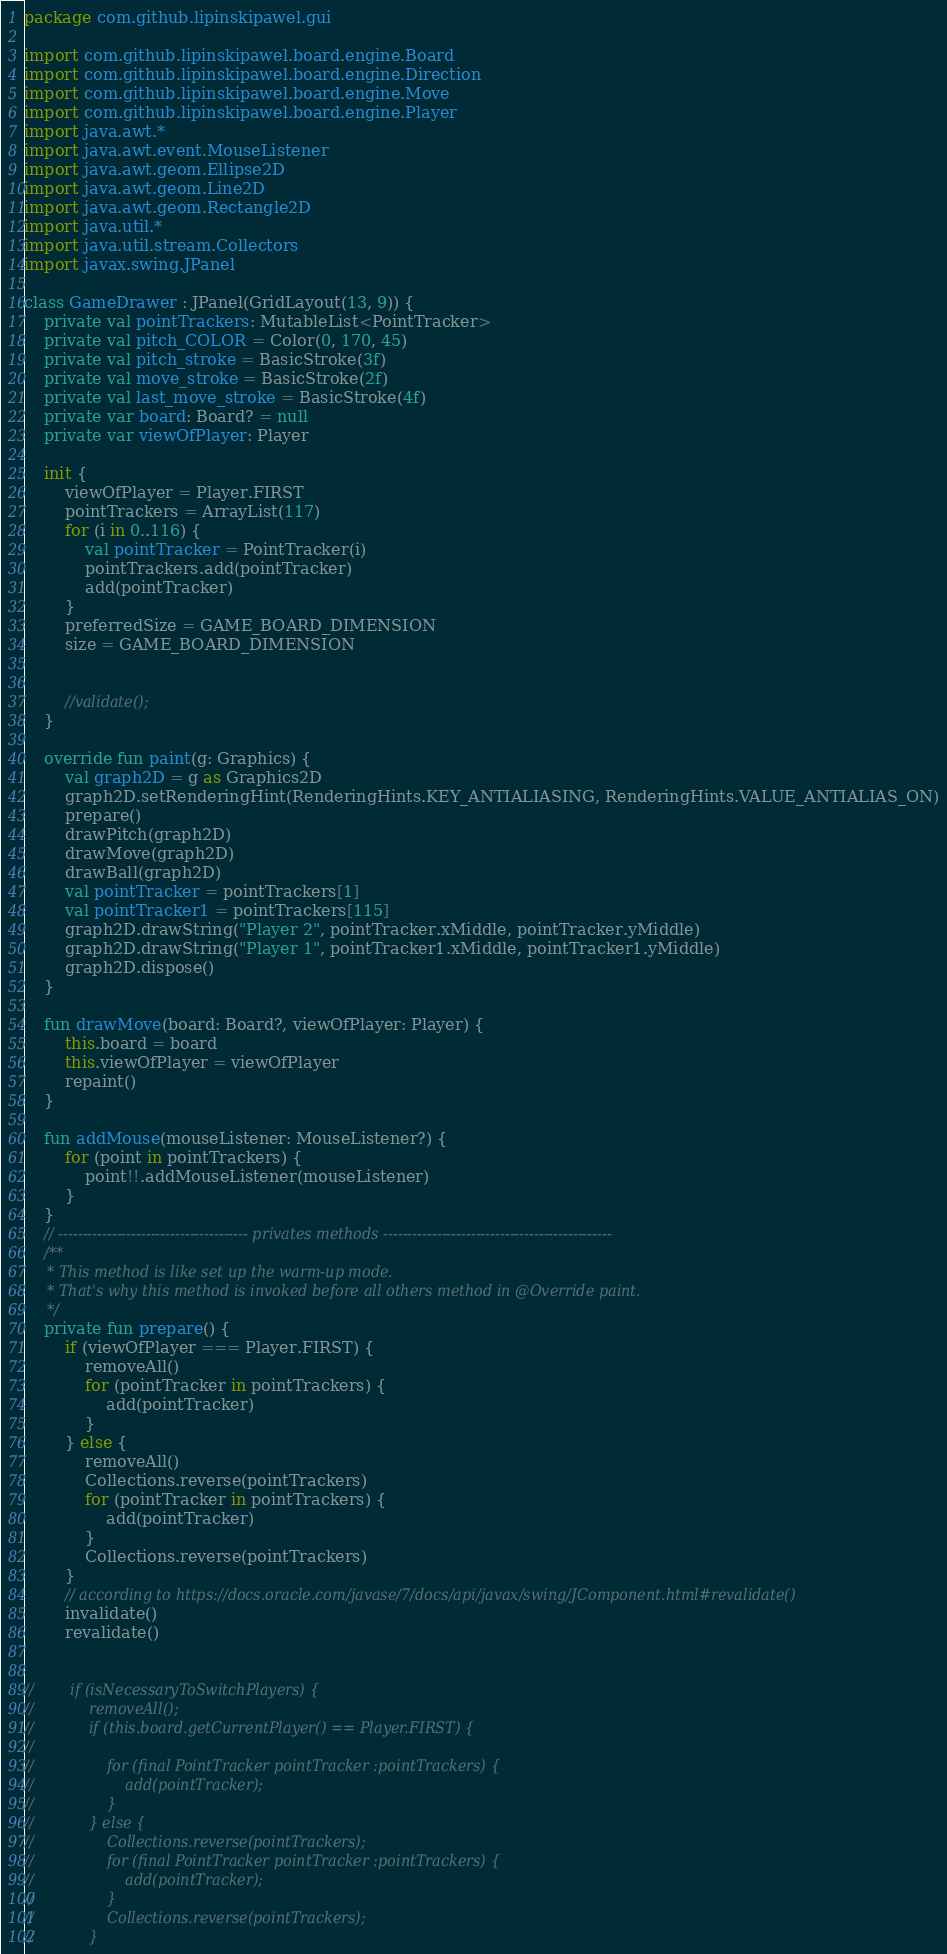Convert code to text. <code><loc_0><loc_0><loc_500><loc_500><_Kotlin_>package com.github.lipinskipawel.gui

import com.github.lipinskipawel.board.engine.Board
import com.github.lipinskipawel.board.engine.Direction
import com.github.lipinskipawel.board.engine.Move
import com.github.lipinskipawel.board.engine.Player
import java.awt.*
import java.awt.event.MouseListener
import java.awt.geom.Ellipse2D
import java.awt.geom.Line2D
import java.awt.geom.Rectangle2D
import java.util.*
import java.util.stream.Collectors
import javax.swing.JPanel

class GameDrawer : JPanel(GridLayout(13, 9)) {
    private val pointTrackers: MutableList<PointTracker>
    private val pitch_COLOR = Color(0, 170, 45)
    private val pitch_stroke = BasicStroke(3f)
    private val move_stroke = BasicStroke(2f)
    private val last_move_stroke = BasicStroke(4f)
    private var board: Board? = null
    private var viewOfPlayer: Player

    init {
        viewOfPlayer = Player.FIRST
        pointTrackers = ArrayList(117)
        for (i in 0..116) {
            val pointTracker = PointTracker(i)
            pointTrackers.add(pointTracker)
            add(pointTracker)
        }
        preferredSize = GAME_BOARD_DIMENSION
        size = GAME_BOARD_DIMENSION


        //validate();
    }

    override fun paint(g: Graphics) {
        val graph2D = g as Graphics2D
        graph2D.setRenderingHint(RenderingHints.KEY_ANTIALIASING, RenderingHints.VALUE_ANTIALIAS_ON)
        prepare()
        drawPitch(graph2D)
        drawMove(graph2D)
        drawBall(graph2D)
        val pointTracker = pointTrackers[1]
        val pointTracker1 = pointTrackers[115]
        graph2D.drawString("Player 2", pointTracker.xMiddle, pointTracker.yMiddle)
        graph2D.drawString("Player 1", pointTracker1.xMiddle, pointTracker1.yMiddle)
        graph2D.dispose()
    }

    fun drawMove(board: Board?, viewOfPlayer: Player) {
        this.board = board
        this.viewOfPlayer = viewOfPlayer
        repaint()
    }

    fun addMouse(mouseListener: MouseListener?) {
        for (point in pointTrackers) {
            point!!.addMouseListener(mouseListener)
        }
    }
    // --------------------------------------- privates methods -----------------------------------------------
    /**
     * This method is like set up the warm-up mode.
     * That's why this method is invoked before all others method in @Override paint.
     */
    private fun prepare() {
        if (viewOfPlayer === Player.FIRST) {
            removeAll()
            for (pointTracker in pointTrackers) {
                add(pointTracker)
            }
        } else {
            removeAll()
            Collections.reverse(pointTrackers)
            for (pointTracker in pointTrackers) {
                add(pointTracker)
            }
            Collections.reverse(pointTrackers)
        }
        // according to https://docs.oracle.com/javase/7/docs/api/javax/swing/JComponent.html#revalidate()
        invalidate()
        revalidate()


//        if (isNecessaryToSwitchPlayers) {
//            removeAll();
//            if (this.board.getCurrentPlayer() == Player.FIRST) {
//
//                for (final PointTracker pointTracker :pointTrackers) {
//                    add(pointTracker);
//                }
//            } else {
//                Collections.reverse(pointTrackers);
//                for (final PointTracker pointTracker :pointTrackers) {
//                    add(pointTracker);
//                }
//                Collections.reverse(pointTrackers);
//            }</code> 